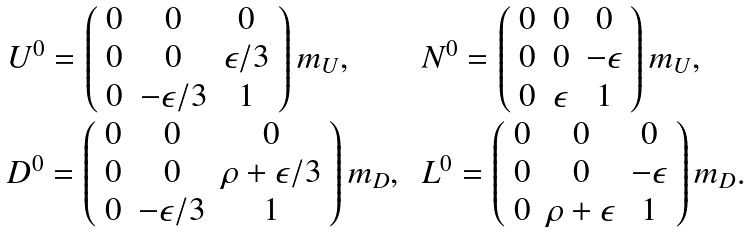Convert formula to latex. <formula><loc_0><loc_0><loc_500><loc_500>\begin{array} { l l } { { U ^ { 0 } = \left ( \begin{array} { c c c } { 0 } & { 0 } & { 0 } \\ { 0 } & { 0 } & { \epsilon / 3 } \\ { 0 } & { - \epsilon / 3 } & { 1 } \end{array} \right ) m _ { U } , } } & { { \, N ^ { 0 } = \left ( \begin{array} { c c c } { 0 } & { 0 } & { 0 } \\ { 0 } & { 0 } & { - \epsilon } \\ { 0 } & { \epsilon } & { 1 } \end{array} \right ) m _ { U } , } } \\ { { D ^ { 0 } = \left ( \begin{array} { c c c } { 0 } & { 0 } & { 0 } \\ { 0 } & { 0 } & { \rho + \epsilon / 3 } \\ { 0 } & { - \epsilon / 3 } & { 1 } \end{array} \right ) m _ { D } , } } & { { \, L ^ { 0 } = \left ( \begin{array} { c c c } { 0 } & { 0 } & { 0 } \\ { 0 } & { 0 } & { - \epsilon } \\ { 0 } & { \rho + \epsilon } & { 1 } \end{array} \right ) m _ { D } . } } \end{array}</formula> 